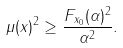Convert formula to latex. <formula><loc_0><loc_0><loc_500><loc_500>\| \mu ( x ) \| ^ { 2 } \geq \frac { F _ { x _ { 0 } } ( \alpha ) ^ { 2 } } { \| \alpha \| ^ { 2 } } .</formula> 